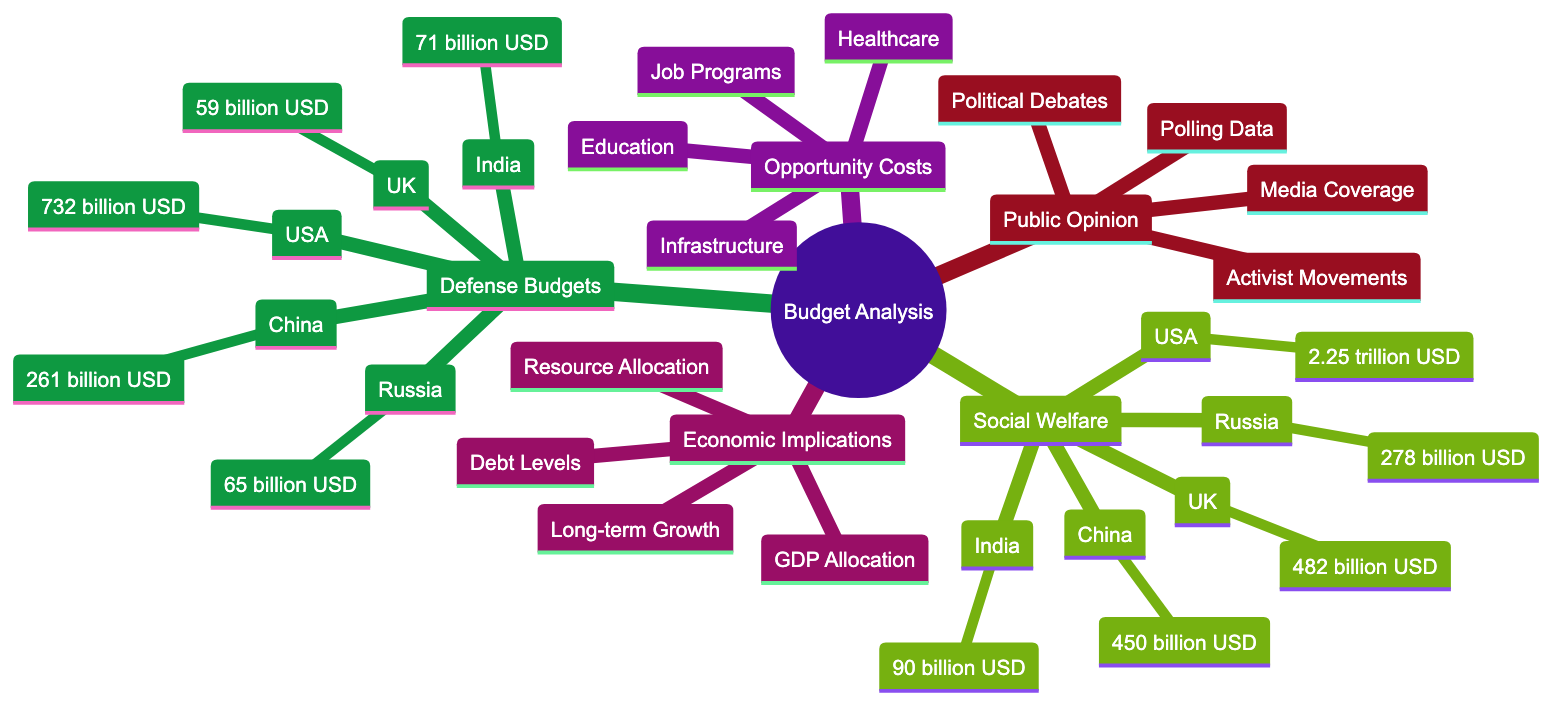What is the defense budget of the USA? The defense budget node for the USA directly states the amount, which is labeled as "732 billion USD."
Answer: 732 billion USD Which country has the highest social welfare expenditure? The social welfare expenditures branch shows that the USA has the highest amount listed, which is "2.25 trillion USD."
Answer: 2.25 trillion USD What is the defense budget of China? The diagram explicitly states that China's defense budget is listed as "261 billion USD."
Answer: 261 billion USD How much does India allocate for social welfare? The diagram provides that India spends "90 billion USD" on social welfare expenditures.
Answer: 90 billion USD What are the opportunity costs mentioned in the mind map? The opportunity costs branch lists four key areas: Education, Healthcare, Infrastructure, and Job Programs.
Answer: Education, Healthcare, Infrastructure, Job Programs Which category shows the economic implications? The economic implications section is directly labeled as such in the mind map and includes topics under this label.
Answer: Economic Implications Which country devotes the least to defense? By comparing the figures in the defense budgets branch, Russia has the least allocation, which is "65 billion USD."
Answer: 65 billion USD What is the role of public opinion in budget analysis according to the diagram? The public opinion branch highlights that it includes Polling Data, Activist Movements, Media Coverage, and Political Debates, indicating the influence of societal views on budget decisions.
Answer: Polling Data, Activist Movements, Media Coverage, Political Debates How does high defense spending affect national debt? The economic implications branch mentions that high defense spending negatively affects Debt Levels, indicating a correlation between the two.
Answer: Debt Levels What type of movements contribute to public opinion as shown in the diagram? The diagram notes that Activist Movements, specifically Peace advocacy and social justice campaigns, play a significant role in shaping public opinion on budget allocations.
Answer: Activist Movements 